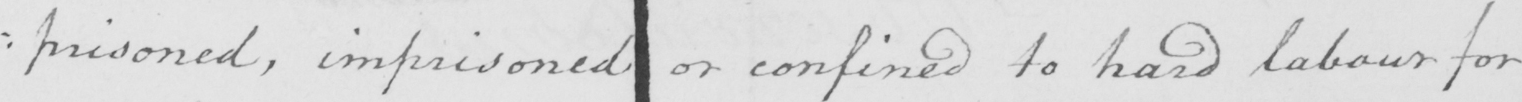What text is written in this handwritten line? : risoned , imprisoned or confined to hard labour for 